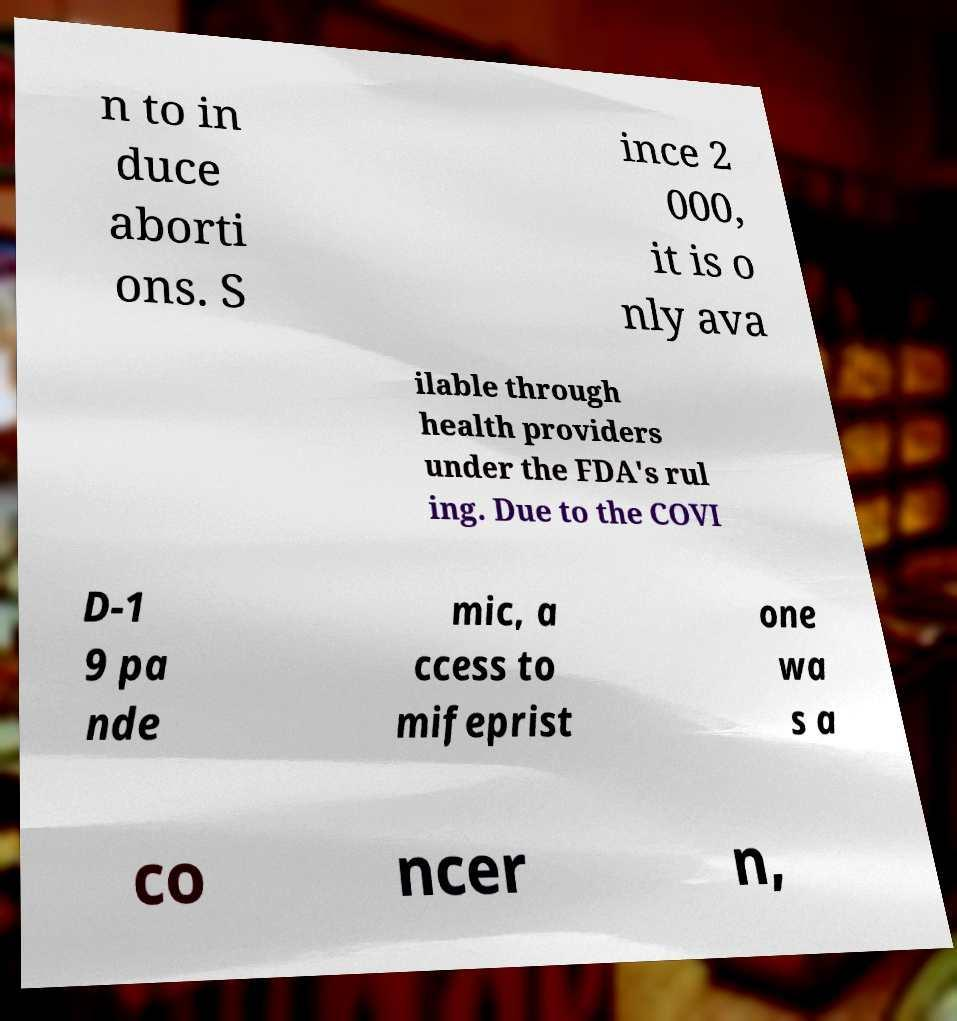Can you read and provide the text displayed in the image?This photo seems to have some interesting text. Can you extract and type it out for me? n to in duce aborti ons. S ince 2 000, it is o nly ava ilable through health providers under the FDA's rul ing. Due to the COVI D-1 9 pa nde mic, a ccess to mifeprist one wa s a co ncer n, 